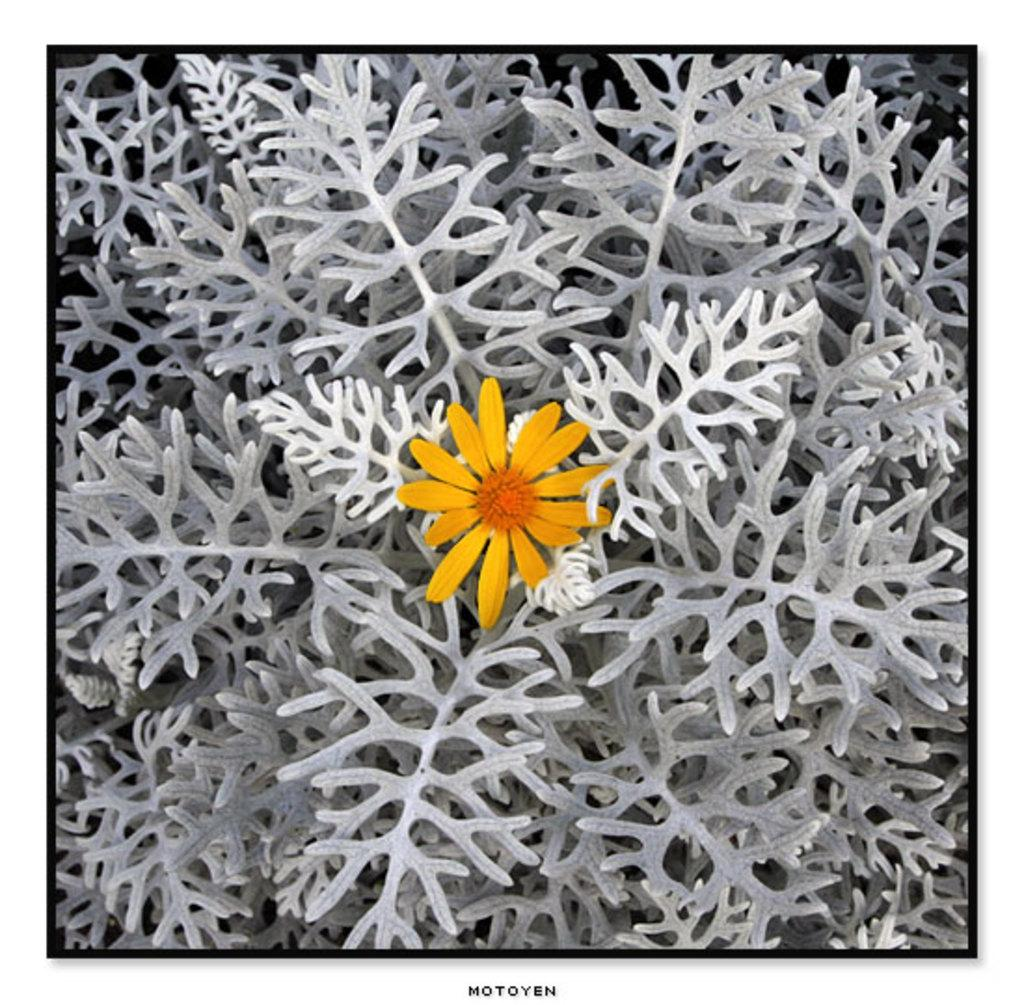What type of plant is visible in the image? There is a flower on a plant in the image. Can you describe the appearance of the image? The image appears to be edited. What additional information is provided at the bottom of the image? There is text at the bottom of the image. How many cows are grazing near the flower in the image? There are no cows present in the image; it features a flower on a plant. What type of fruit is hanging from the plant in the image? There is no fruit visible in the image, only a flower on a plant. 